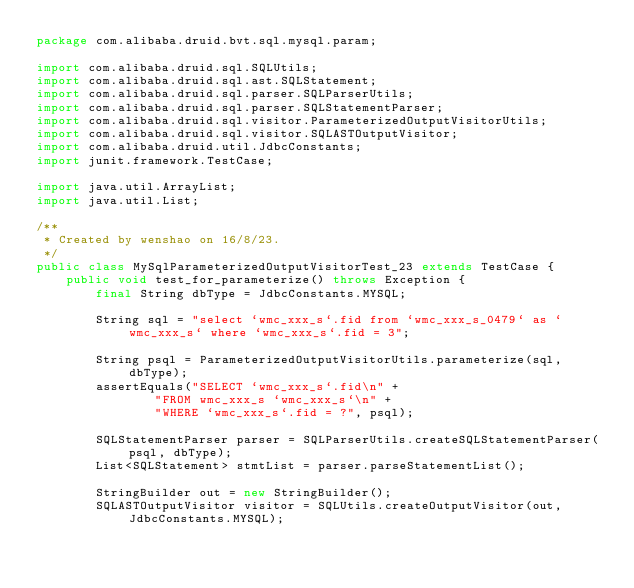Convert code to text. <code><loc_0><loc_0><loc_500><loc_500><_Java_>package com.alibaba.druid.bvt.sql.mysql.param;

import com.alibaba.druid.sql.SQLUtils;
import com.alibaba.druid.sql.ast.SQLStatement;
import com.alibaba.druid.sql.parser.SQLParserUtils;
import com.alibaba.druid.sql.parser.SQLStatementParser;
import com.alibaba.druid.sql.visitor.ParameterizedOutputVisitorUtils;
import com.alibaba.druid.sql.visitor.SQLASTOutputVisitor;
import com.alibaba.druid.util.JdbcConstants;
import junit.framework.TestCase;

import java.util.ArrayList;
import java.util.List;

/**
 * Created by wenshao on 16/8/23.
 */
public class MySqlParameterizedOutputVisitorTest_23 extends TestCase {
    public void test_for_parameterize() throws Exception {
        final String dbType = JdbcConstants.MYSQL;

        String sql = "select `wmc_xxx_s`.fid from `wmc_xxx_s_0479` as `wmc_xxx_s` where `wmc_xxx_s`.fid = 3";

        String psql = ParameterizedOutputVisitorUtils.parameterize(sql, dbType);
        assertEquals("SELECT `wmc_xxx_s`.fid\n" +
                "FROM wmc_xxx_s `wmc_xxx_s`\n" +
                "WHERE `wmc_xxx_s`.fid = ?", psql);

        SQLStatementParser parser = SQLParserUtils.createSQLStatementParser(psql, dbType);
        List<SQLStatement> stmtList = parser.parseStatementList();

        StringBuilder out = new StringBuilder();
        SQLASTOutputVisitor visitor = SQLUtils.createOutputVisitor(out, JdbcConstants.MYSQL);</code> 